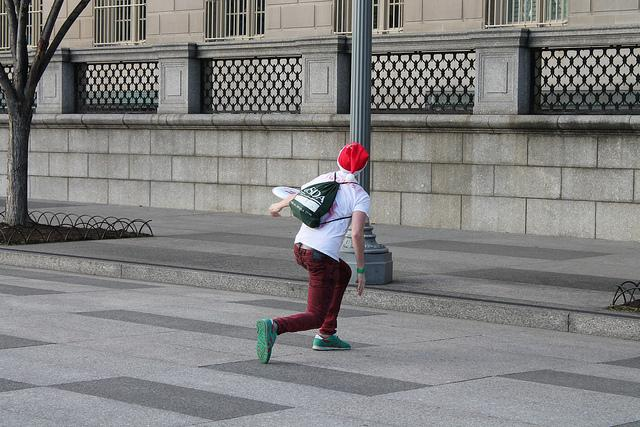What is the man doing?

Choices:
A) sleeping
B) drinking
C) working out
D) running running 